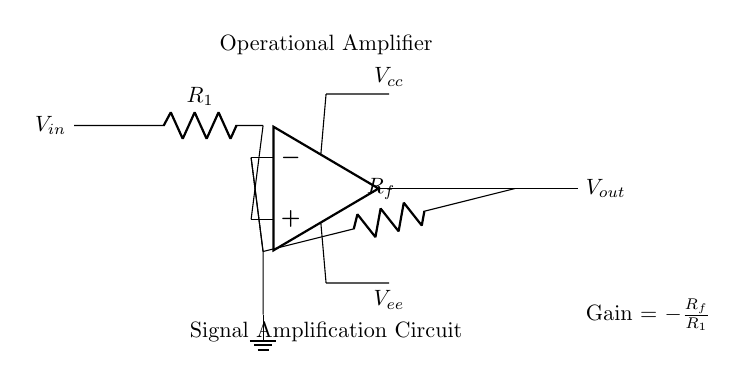What is the input voltage labeled in the circuit? The input voltage is denoted as "V_in," which appears on the left side of the operational amplifier circuit diagram.
Answer: V_in What are the resistance values present in the circuit? The circuit includes two resistances: R_1, which is connected to the input, and R_f, which is part of the feedback loop.
Answer: R_1 and R_f What does the operational amplifier do in this circuit? The operational amplifier amplifies the voltage signal applied at the input (V_in), as indicated by the configuration of the components and the gain equation shown.
Answer: Amplification What is the gain equation provided in the circuit? The gain equation is shown at the bottom of the diagram, indicating the relationship between the resistances and the output voltage. It states that Gain = -R_f/R_1.
Answer: Gain = -R_f/R_1 Which node is grounded in this circuit? The circuit has a grounded node labeled directly as "ground," which is located at the negative input side of the operational amplifier.
Answer: Ground What is the output voltage labeled in the circuit? The output voltage is denoted as "V_out," which is shown on the right side of the operational amplifier and indicates the amplified voltage output.
Answer: V_out What type of configuration does this operational amplifier circuit demonstrate? This operational amplifier circuit demonstrates an inverting configuration, evidenced by the placement of R_1 at the input and R_f in the feedback loop, which drives the output inversely proportional to the input voltage.
Answer: Inverting configuration 